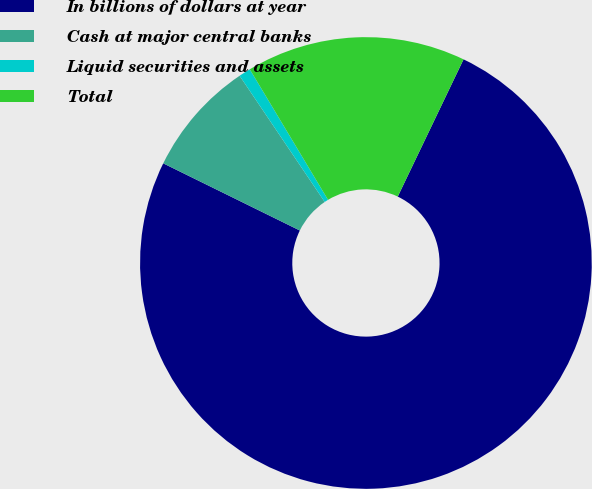<chart> <loc_0><loc_0><loc_500><loc_500><pie_chart><fcel>In billions of dollars at year<fcel>Cash at major central banks<fcel>Liquid securities and assets<fcel>Total<nl><fcel>75.15%<fcel>8.28%<fcel>0.85%<fcel>15.71%<nl></chart> 